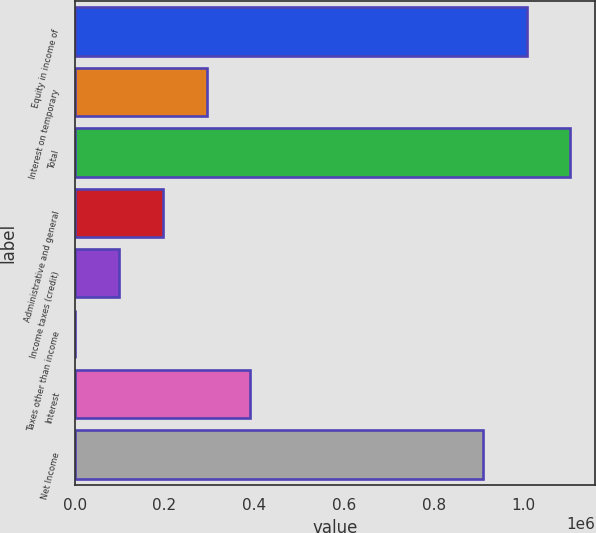Convert chart to OTSL. <chart><loc_0><loc_0><loc_500><loc_500><bar_chart><fcel>Equity in income of<fcel>Interest on temporary<fcel>Total<fcel>Administrative and general<fcel>Income taxes (credit)<fcel>Taxes other than income<fcel>Interest<fcel>Net Income<nl><fcel>1.00683e+06<fcel>293674<fcel>1.10414e+06<fcel>196367<fcel>99060.6<fcel>1754<fcel>390980<fcel>909524<nl></chart> 